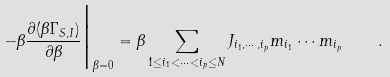Convert formula to latex. <formula><loc_0><loc_0><loc_500><loc_500>- \beta \frac { \partial ( \beta \Gamma _ { S , I } ) } { \partial \beta } { \Big | } _ { \beta = 0 } = \beta \sum _ { 1 \leq i _ { 1 } < \cdots < i _ { p } \leq N } J _ { i _ { 1 } , \cdots , i _ { p } } m _ { i _ { 1 } } \cdots m _ { i _ { p } } \quad .</formula> 